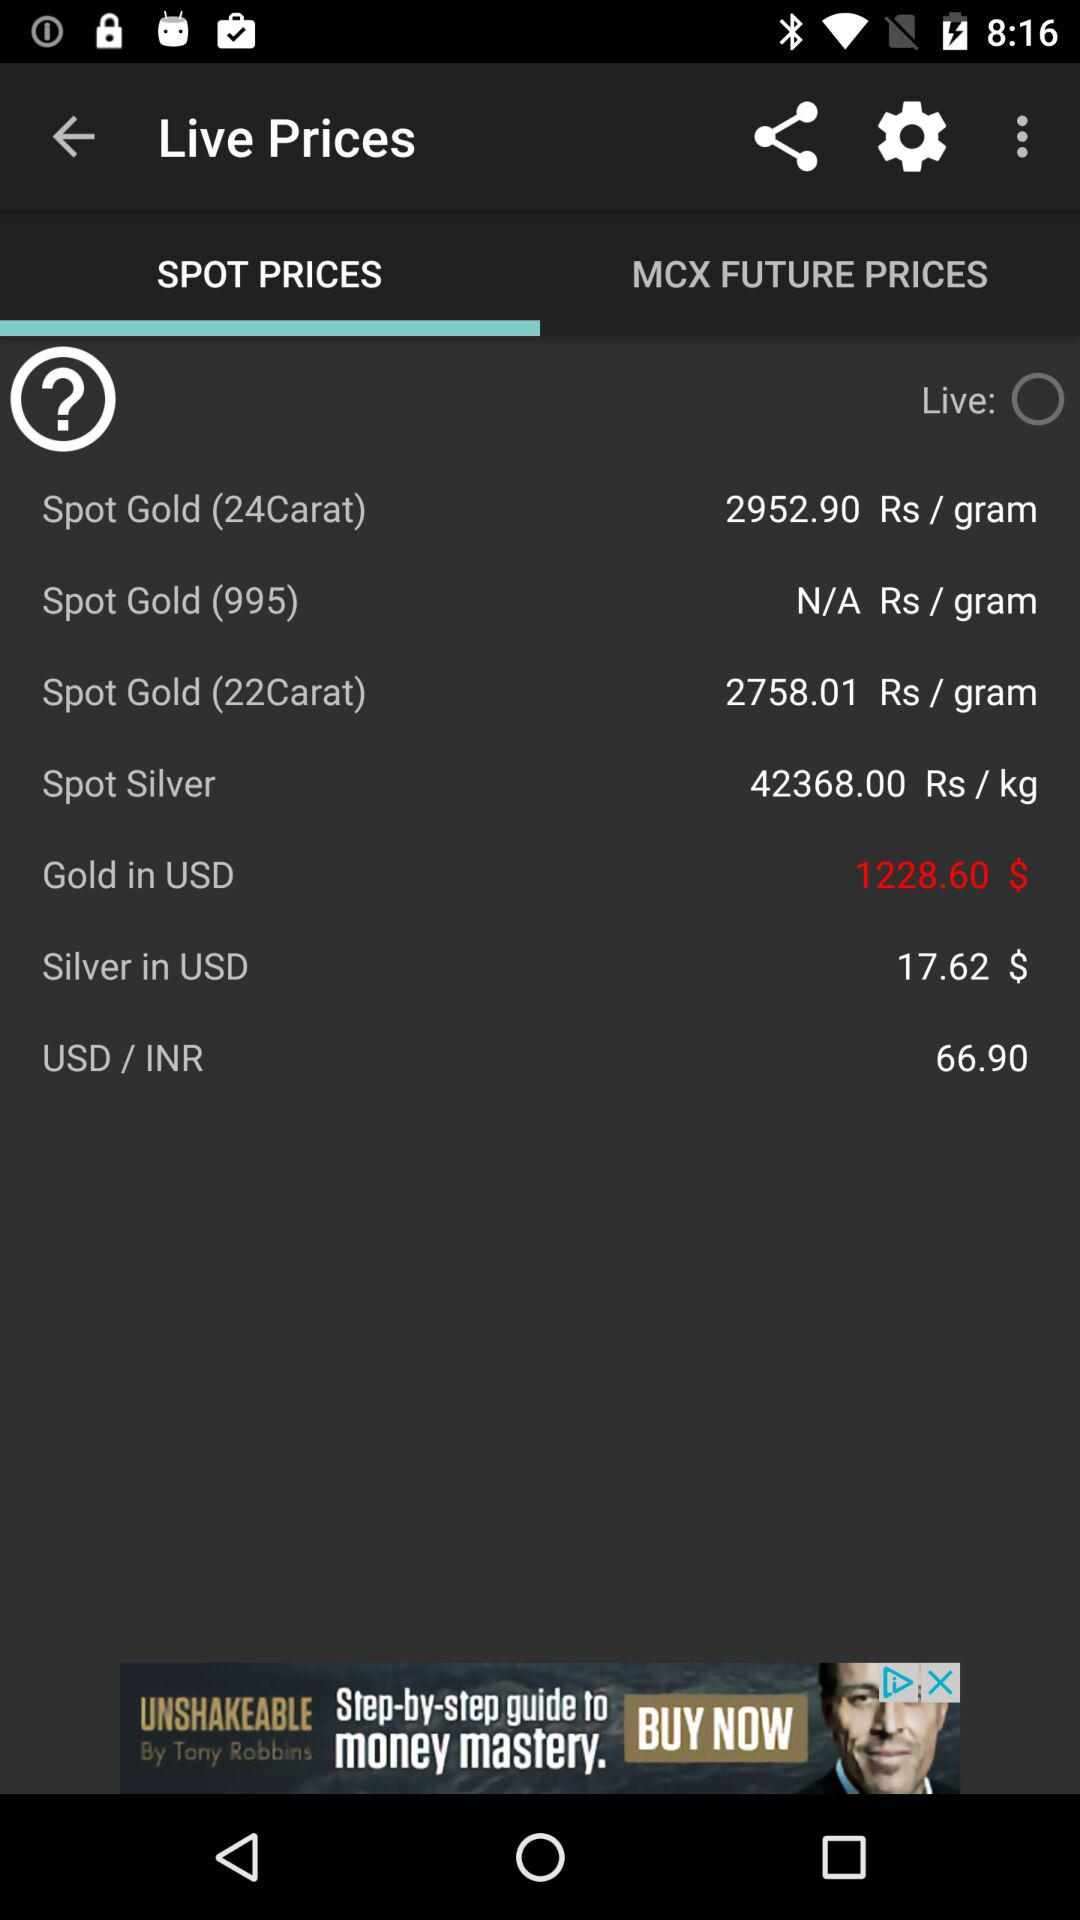What is the USD/INR price? The USD/INR price is 66.90. 